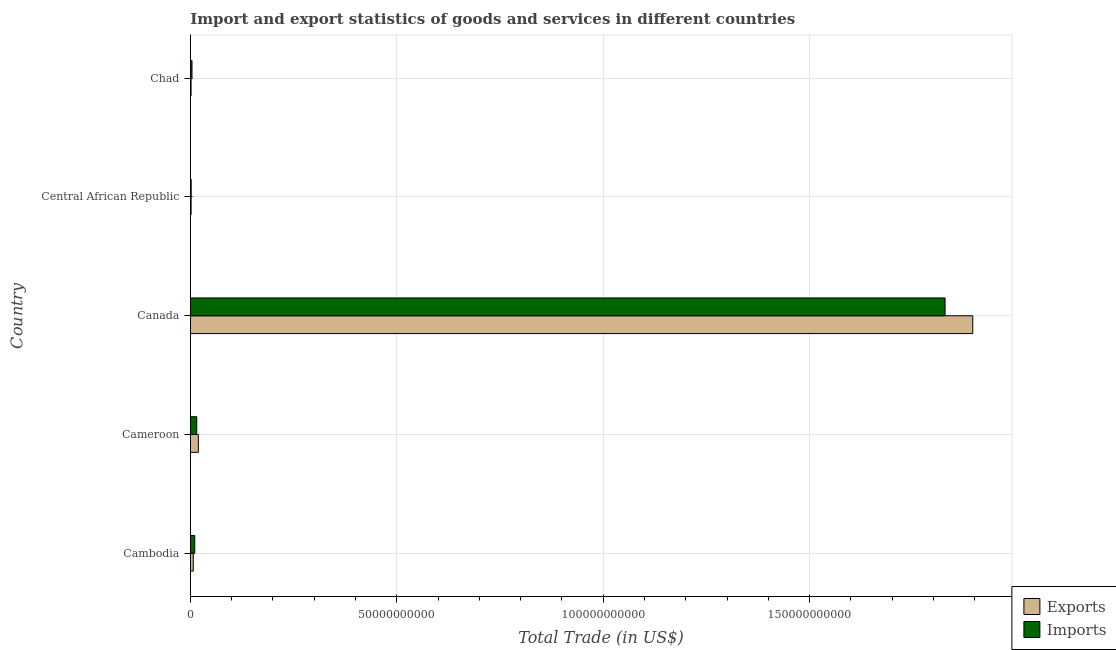How many different coloured bars are there?
Offer a terse response. 2. How many groups of bars are there?
Provide a succinct answer. 5. How many bars are there on the 3rd tick from the top?
Offer a terse response. 2. What is the label of the 4th group of bars from the top?
Give a very brief answer. Cameroon. In how many cases, is the number of bars for a given country not equal to the number of legend labels?
Your answer should be compact. 0. What is the export of goods and services in Cameroon?
Your answer should be compact. 1.95e+09. Across all countries, what is the maximum imports of goods and services?
Offer a terse response. 1.83e+11. Across all countries, what is the minimum imports of goods and services?
Ensure brevity in your answer.  2.13e+08. In which country was the export of goods and services maximum?
Keep it short and to the point. Canada. In which country was the export of goods and services minimum?
Provide a succinct answer. Chad. What is the total export of goods and services in the graph?
Your answer should be compact. 1.93e+11. What is the difference between the imports of goods and services in Cameroon and that in Chad?
Provide a short and direct response. 1.15e+09. What is the difference between the imports of goods and services in Cameroon and the export of goods and services in Canada?
Provide a short and direct response. -1.88e+11. What is the average imports of goods and services per country?
Offer a very short reply. 3.72e+1. What is the difference between the export of goods and services and imports of goods and services in Cambodia?
Give a very brief answer. -3.60e+08. What is the ratio of the export of goods and services in Cameroon to that in Central African Republic?
Offer a very short reply. 9.78. What is the difference between the highest and the second highest imports of goods and services?
Offer a very short reply. 1.81e+11. What is the difference between the highest and the lowest export of goods and services?
Offer a terse response. 1.89e+11. Is the sum of the imports of goods and services in Cambodia and Canada greater than the maximum export of goods and services across all countries?
Keep it short and to the point. No. What does the 2nd bar from the top in Cambodia represents?
Your answer should be very brief. Exports. What does the 1st bar from the bottom in Canada represents?
Provide a short and direct response. Exports. How many bars are there?
Ensure brevity in your answer.  10. How many countries are there in the graph?
Provide a short and direct response. 5. What is the difference between two consecutive major ticks on the X-axis?
Offer a very short reply. 5.00e+1. Does the graph contain any zero values?
Make the answer very short. No. Does the graph contain grids?
Your answer should be compact. Yes. How many legend labels are there?
Provide a succinct answer. 2. What is the title of the graph?
Your answer should be very brief. Import and export statistics of goods and services in different countries. Does "External balance on goods" appear as one of the legend labels in the graph?
Provide a succinct answer. No. What is the label or title of the X-axis?
Your answer should be very brief. Total Trade (in US$). What is the label or title of the Y-axis?
Make the answer very short. Country. What is the Total Trade (in US$) in Exports in Cambodia?
Make the answer very short. 7.20e+08. What is the Total Trade (in US$) in Imports in Cambodia?
Your answer should be compact. 1.08e+09. What is the Total Trade (in US$) of Exports in Cameroon?
Give a very brief answer. 1.95e+09. What is the Total Trade (in US$) in Imports in Cameroon?
Ensure brevity in your answer.  1.56e+09. What is the Total Trade (in US$) in Exports in Canada?
Keep it short and to the point. 1.90e+11. What is the Total Trade (in US$) in Imports in Canada?
Offer a terse response. 1.83e+11. What is the Total Trade (in US$) of Exports in Central African Republic?
Make the answer very short. 1.99e+08. What is the Total Trade (in US$) of Imports in Central African Republic?
Make the answer very short. 2.13e+08. What is the Total Trade (in US$) of Exports in Chad?
Offer a terse response. 1.90e+08. What is the Total Trade (in US$) of Imports in Chad?
Offer a very short reply. 4.12e+08. Across all countries, what is the maximum Total Trade (in US$) of Exports?
Offer a very short reply. 1.90e+11. Across all countries, what is the maximum Total Trade (in US$) of Imports?
Your answer should be compact. 1.83e+11. Across all countries, what is the minimum Total Trade (in US$) in Exports?
Your answer should be very brief. 1.90e+08. Across all countries, what is the minimum Total Trade (in US$) in Imports?
Keep it short and to the point. 2.13e+08. What is the total Total Trade (in US$) in Exports in the graph?
Provide a succinct answer. 1.93e+11. What is the total Total Trade (in US$) in Imports in the graph?
Keep it short and to the point. 1.86e+11. What is the difference between the Total Trade (in US$) in Exports in Cambodia and that in Cameroon?
Provide a succinct answer. -1.23e+09. What is the difference between the Total Trade (in US$) of Imports in Cambodia and that in Cameroon?
Make the answer very short. -4.79e+08. What is the difference between the Total Trade (in US$) of Exports in Cambodia and that in Canada?
Provide a short and direct response. -1.89e+11. What is the difference between the Total Trade (in US$) in Imports in Cambodia and that in Canada?
Provide a short and direct response. -1.82e+11. What is the difference between the Total Trade (in US$) of Exports in Cambodia and that in Central African Republic?
Give a very brief answer. 5.21e+08. What is the difference between the Total Trade (in US$) in Imports in Cambodia and that in Central African Republic?
Your answer should be very brief. 8.67e+08. What is the difference between the Total Trade (in US$) of Exports in Cambodia and that in Chad?
Give a very brief answer. 5.30e+08. What is the difference between the Total Trade (in US$) of Imports in Cambodia and that in Chad?
Your response must be concise. 6.68e+08. What is the difference between the Total Trade (in US$) in Exports in Cameroon and that in Canada?
Offer a very short reply. -1.88e+11. What is the difference between the Total Trade (in US$) in Imports in Cameroon and that in Canada?
Offer a very short reply. -1.81e+11. What is the difference between the Total Trade (in US$) in Exports in Cameroon and that in Central African Republic?
Provide a succinct answer. 1.75e+09. What is the difference between the Total Trade (in US$) of Imports in Cameroon and that in Central African Republic?
Keep it short and to the point. 1.35e+09. What is the difference between the Total Trade (in US$) in Exports in Cameroon and that in Chad?
Your answer should be very brief. 1.76e+09. What is the difference between the Total Trade (in US$) in Imports in Cameroon and that in Chad?
Offer a very short reply. 1.15e+09. What is the difference between the Total Trade (in US$) in Exports in Canada and that in Central African Republic?
Give a very brief answer. 1.89e+11. What is the difference between the Total Trade (in US$) in Imports in Canada and that in Central African Republic?
Give a very brief answer. 1.83e+11. What is the difference between the Total Trade (in US$) of Exports in Canada and that in Chad?
Give a very brief answer. 1.89e+11. What is the difference between the Total Trade (in US$) in Imports in Canada and that in Chad?
Your answer should be compact. 1.82e+11. What is the difference between the Total Trade (in US$) of Exports in Central African Republic and that in Chad?
Offer a very short reply. 9.15e+06. What is the difference between the Total Trade (in US$) in Imports in Central African Republic and that in Chad?
Provide a short and direct response. -1.99e+08. What is the difference between the Total Trade (in US$) of Exports in Cambodia and the Total Trade (in US$) of Imports in Cameroon?
Your response must be concise. -8.39e+08. What is the difference between the Total Trade (in US$) in Exports in Cambodia and the Total Trade (in US$) in Imports in Canada?
Your answer should be compact. -1.82e+11. What is the difference between the Total Trade (in US$) of Exports in Cambodia and the Total Trade (in US$) of Imports in Central African Republic?
Your response must be concise. 5.07e+08. What is the difference between the Total Trade (in US$) of Exports in Cambodia and the Total Trade (in US$) of Imports in Chad?
Ensure brevity in your answer.  3.08e+08. What is the difference between the Total Trade (in US$) in Exports in Cameroon and the Total Trade (in US$) in Imports in Canada?
Offer a terse response. -1.81e+11. What is the difference between the Total Trade (in US$) in Exports in Cameroon and the Total Trade (in US$) in Imports in Central African Republic?
Your answer should be very brief. 1.73e+09. What is the difference between the Total Trade (in US$) in Exports in Cameroon and the Total Trade (in US$) in Imports in Chad?
Your answer should be very brief. 1.54e+09. What is the difference between the Total Trade (in US$) of Exports in Canada and the Total Trade (in US$) of Imports in Central African Republic?
Offer a terse response. 1.89e+11. What is the difference between the Total Trade (in US$) in Exports in Canada and the Total Trade (in US$) in Imports in Chad?
Ensure brevity in your answer.  1.89e+11. What is the difference between the Total Trade (in US$) of Exports in Central African Republic and the Total Trade (in US$) of Imports in Chad?
Make the answer very short. -2.12e+08. What is the average Total Trade (in US$) of Exports per country?
Offer a very short reply. 3.85e+1. What is the average Total Trade (in US$) of Imports per country?
Keep it short and to the point. 3.72e+1. What is the difference between the Total Trade (in US$) of Exports and Total Trade (in US$) of Imports in Cambodia?
Keep it short and to the point. -3.60e+08. What is the difference between the Total Trade (in US$) in Exports and Total Trade (in US$) in Imports in Cameroon?
Your response must be concise. 3.89e+08. What is the difference between the Total Trade (in US$) of Exports and Total Trade (in US$) of Imports in Canada?
Keep it short and to the point. 6.71e+09. What is the difference between the Total Trade (in US$) in Exports and Total Trade (in US$) in Imports in Central African Republic?
Ensure brevity in your answer.  -1.38e+07. What is the difference between the Total Trade (in US$) in Exports and Total Trade (in US$) in Imports in Chad?
Provide a succinct answer. -2.22e+08. What is the ratio of the Total Trade (in US$) of Exports in Cambodia to that in Cameroon?
Provide a succinct answer. 0.37. What is the ratio of the Total Trade (in US$) in Imports in Cambodia to that in Cameroon?
Keep it short and to the point. 0.69. What is the ratio of the Total Trade (in US$) in Exports in Cambodia to that in Canada?
Offer a very short reply. 0. What is the ratio of the Total Trade (in US$) of Imports in Cambodia to that in Canada?
Your answer should be compact. 0.01. What is the ratio of the Total Trade (in US$) in Exports in Cambodia to that in Central African Republic?
Your answer should be very brief. 3.61. What is the ratio of the Total Trade (in US$) of Imports in Cambodia to that in Central African Republic?
Give a very brief answer. 5.07. What is the ratio of the Total Trade (in US$) in Exports in Cambodia to that in Chad?
Ensure brevity in your answer.  3.79. What is the ratio of the Total Trade (in US$) in Imports in Cambodia to that in Chad?
Provide a short and direct response. 2.62. What is the ratio of the Total Trade (in US$) in Exports in Cameroon to that in Canada?
Give a very brief answer. 0.01. What is the ratio of the Total Trade (in US$) of Imports in Cameroon to that in Canada?
Your response must be concise. 0.01. What is the ratio of the Total Trade (in US$) in Exports in Cameroon to that in Central African Republic?
Give a very brief answer. 9.78. What is the ratio of the Total Trade (in US$) in Imports in Cameroon to that in Central African Republic?
Provide a short and direct response. 7.32. What is the ratio of the Total Trade (in US$) in Exports in Cameroon to that in Chad?
Your answer should be very brief. 10.25. What is the ratio of the Total Trade (in US$) in Imports in Cameroon to that in Chad?
Keep it short and to the point. 3.79. What is the ratio of the Total Trade (in US$) of Exports in Canada to that in Central African Republic?
Keep it short and to the point. 951.5. What is the ratio of the Total Trade (in US$) in Imports in Canada to that in Central African Republic?
Provide a short and direct response. 858.42. What is the ratio of the Total Trade (in US$) of Exports in Canada to that in Chad?
Provide a short and direct response. 997.31. What is the ratio of the Total Trade (in US$) of Imports in Canada to that in Chad?
Your answer should be compact. 444.17. What is the ratio of the Total Trade (in US$) in Exports in Central African Republic to that in Chad?
Your answer should be very brief. 1.05. What is the ratio of the Total Trade (in US$) in Imports in Central African Republic to that in Chad?
Your answer should be compact. 0.52. What is the difference between the highest and the second highest Total Trade (in US$) of Exports?
Offer a very short reply. 1.88e+11. What is the difference between the highest and the second highest Total Trade (in US$) in Imports?
Your answer should be compact. 1.81e+11. What is the difference between the highest and the lowest Total Trade (in US$) in Exports?
Provide a short and direct response. 1.89e+11. What is the difference between the highest and the lowest Total Trade (in US$) of Imports?
Your answer should be compact. 1.83e+11. 